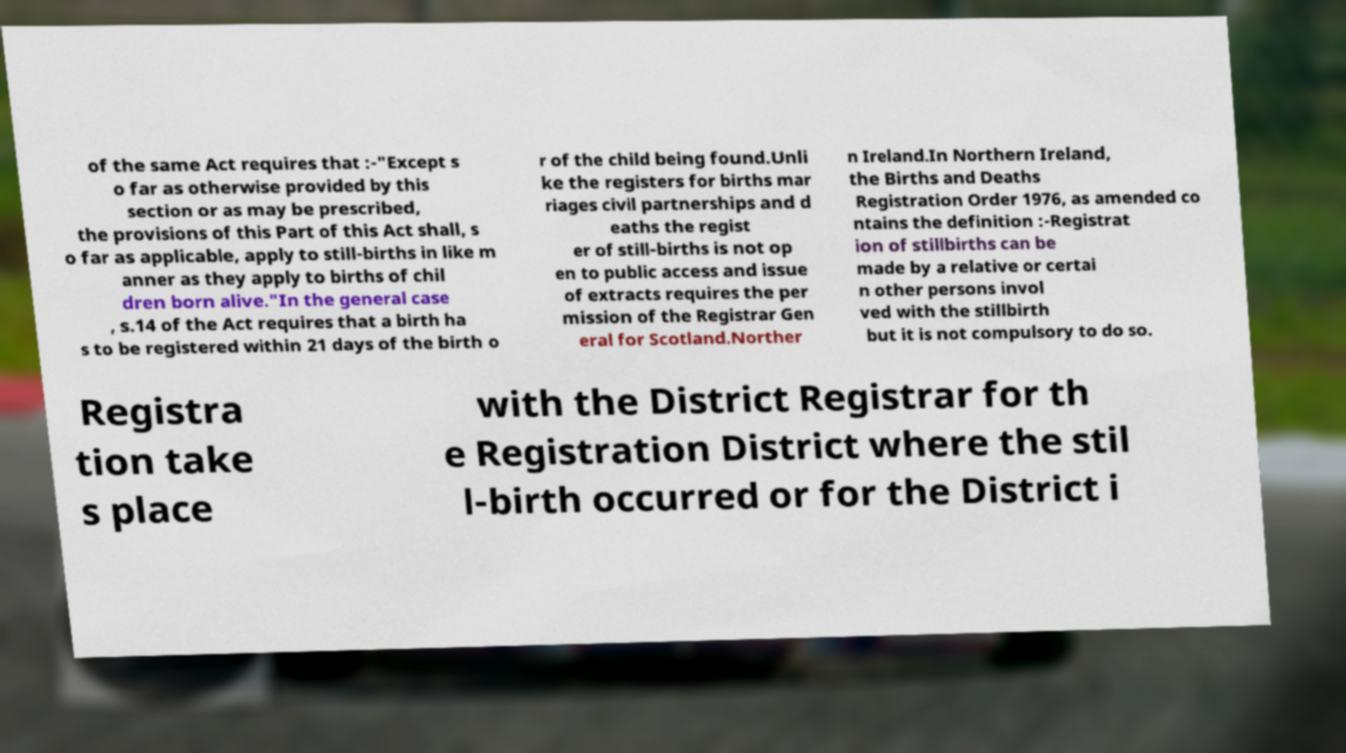Could you assist in decoding the text presented in this image and type it out clearly? of the same Act requires that :-"Except s o far as otherwise provided by this section or as may be prescribed, the provisions of this Part of this Act shall, s o far as applicable, apply to still-births in like m anner as they apply to births of chil dren born alive."In the general case , s.14 of the Act requires that a birth ha s to be registered within 21 days of the birth o r of the child being found.Unli ke the registers for births mar riages civil partnerships and d eaths the regist er of still-births is not op en to public access and issue of extracts requires the per mission of the Registrar Gen eral for Scotland.Norther n Ireland.In Northern Ireland, the Births and Deaths Registration Order 1976, as amended co ntains the definition :-Registrat ion of stillbirths can be made by a relative or certai n other persons invol ved with the stillbirth but it is not compulsory to do so. Registra tion take s place with the District Registrar for th e Registration District where the stil l-birth occurred or for the District i 